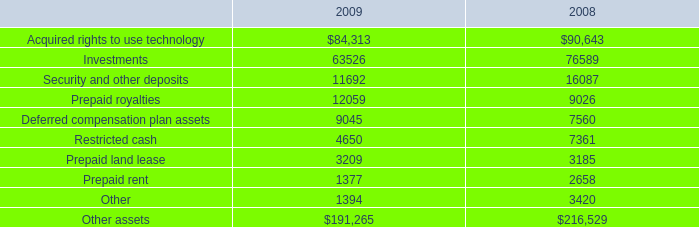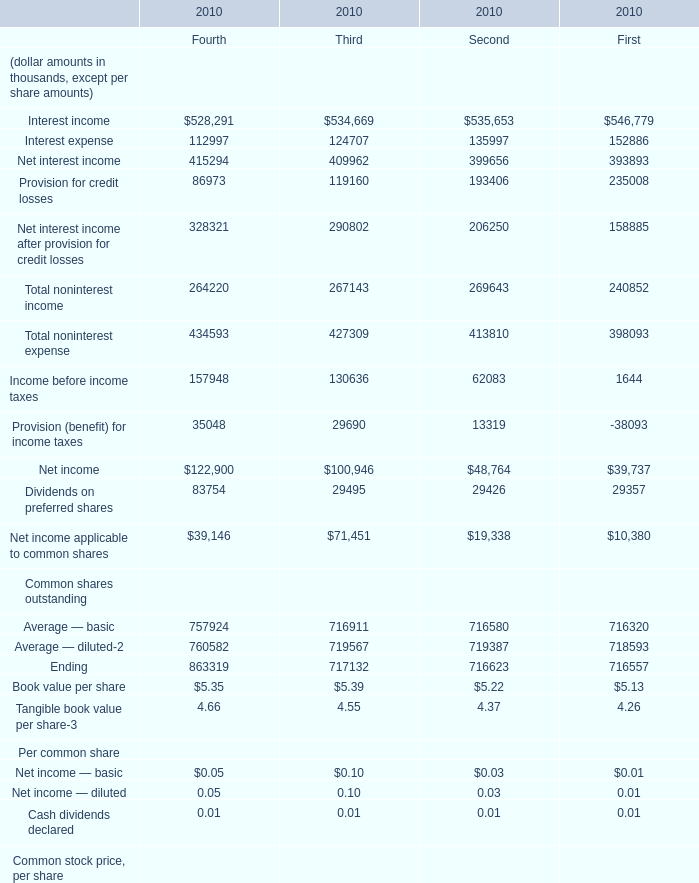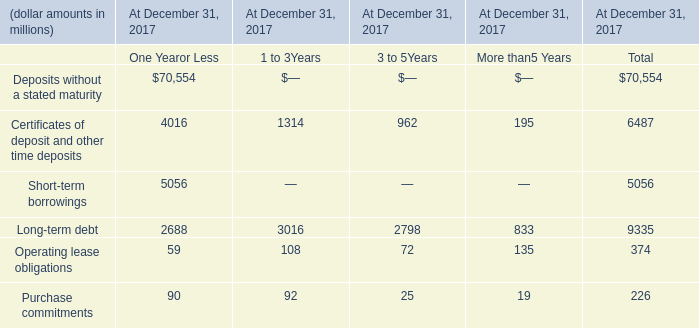Which quarter is Provision for credit losses the largest in 2010? 
Answer: 4. 